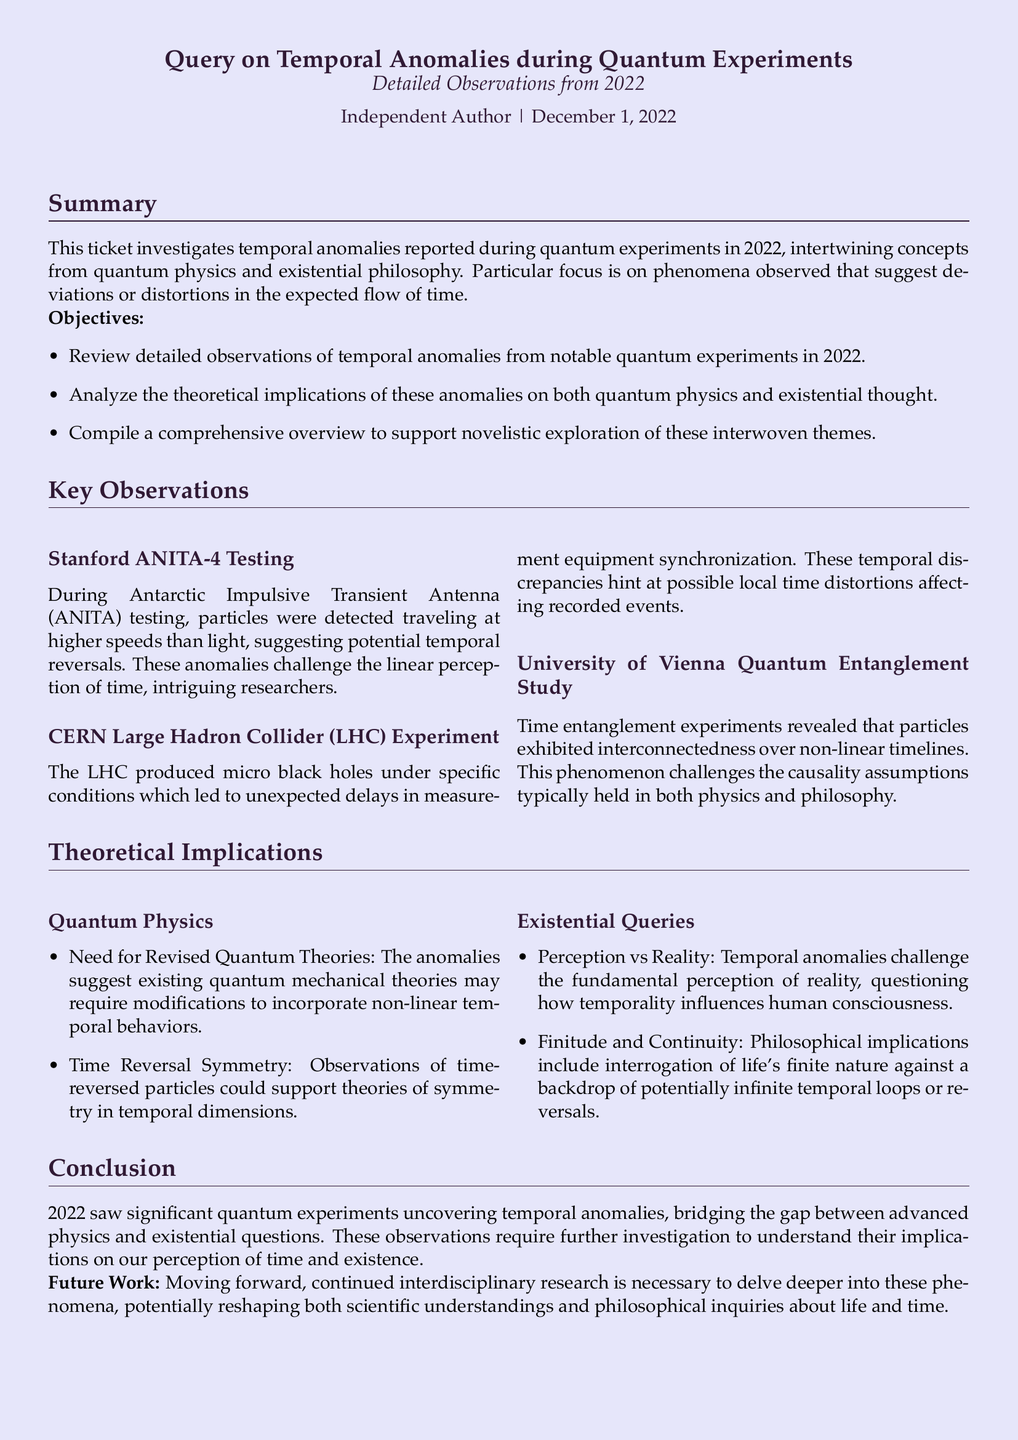What is the title of the ticket? The title is the subject of the document outlined at the beginning, which describes the focus of the investigation.
Answer: Query on Temporal Anomalies during Quantum Experiments What year do the detailed observations pertain to? The observations are explicitly noted in the document with a reference to the timeline of discussions.
Answer: 2022 Which experiment detected particles traveling faster than light? The specific experiment where anomalies were reported includes the name of the testing facility involved.
Answer: Stanford ANITA-4 Testing What phenomena were produced by the CERN Large Hadron Collider? The document summarizes the unexpected results from the experiment that were specifically mentioned.
Answer: Micro black holes What concept challenges causality assumptions in quantum physics? The study described in the document indicates that one phenomenon affects the understanding of time and connections between particles.
Answer: Time entanglement Which philosophical implication is associated with perception versus reality? The document outlines philosophical questions arising from the observations made during experiments, summarizing the existential concerns.
Answer: Temporal anomalies What is one proposed future action mentioned in the document? The document suggests further necessary actions that should be taken regarding the investigations already conducted.
Answer: Continued interdisciplinary research Which organization conducted a quantum entanglement study? The name of the university is specified in the document where innovative studies are performed.
Answer: University of Vienna 